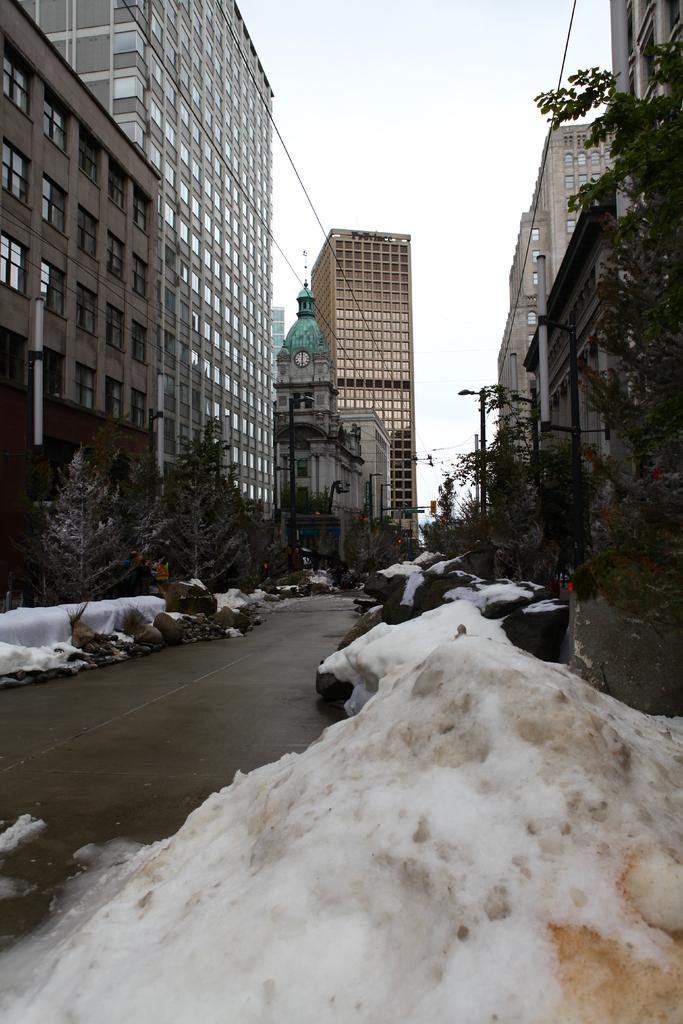How would you summarize this image in a sentence or two? In the picture we can see a street, in the street we can see a road and on either sides we can see some plants and trees and snow and we can also see buildings on the either sides with a windows and in the background also we can see buildings with a clock and to the path we can see some poles with lights and a sky. 